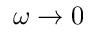Convert formula to latex. <formula><loc_0><loc_0><loc_500><loc_500>\omega \rightarrow 0</formula> 